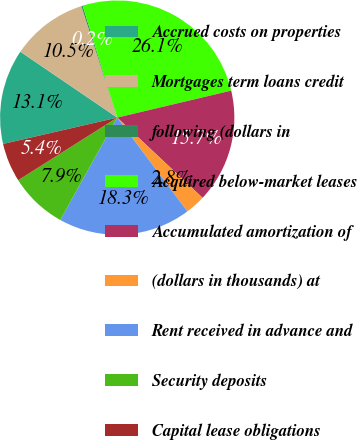Convert chart to OTSL. <chart><loc_0><loc_0><loc_500><loc_500><pie_chart><fcel>Accrued costs on properties<fcel>Mortgages term loans credit<fcel>following (dollars in<fcel>Acquired below-market leases<fcel>Accumulated amortization of<fcel>(dollars in thousands) at<fcel>Rent received in advance and<fcel>Security deposits<fcel>Capital lease obligations<nl><fcel>13.12%<fcel>10.54%<fcel>0.18%<fcel>26.07%<fcel>15.71%<fcel>2.77%<fcel>18.3%<fcel>7.95%<fcel>5.36%<nl></chart> 